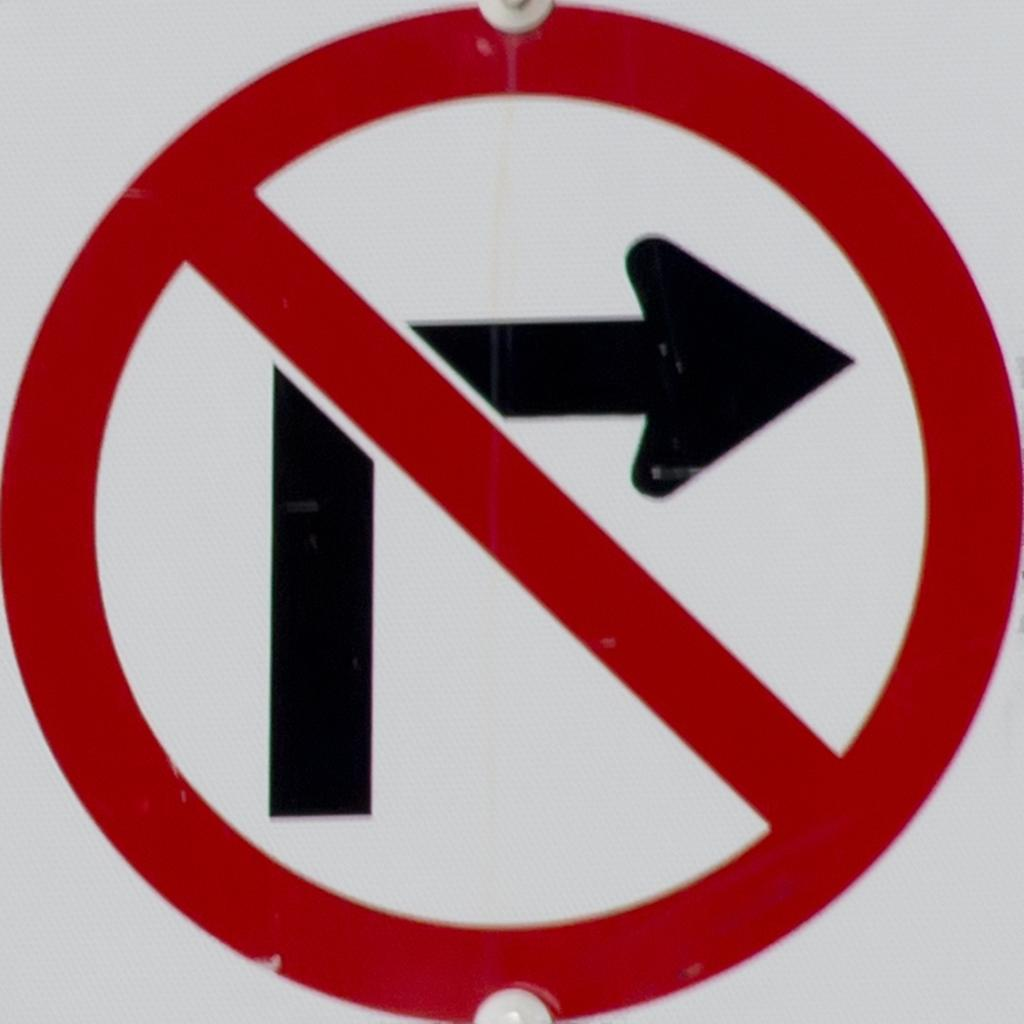What type of sign is visible in the image? There is a "No turn right" sign in the image. What color is the sign? The color of the sign is not mentioned in the facts, so we cannot determine its color. What is the background color of the image? The background of the image is white. What is the name of the daughter of the secretary of the nation in the image? There is no mention of a daughter, secretary, or nation in the image, so we cannot answer this question. 